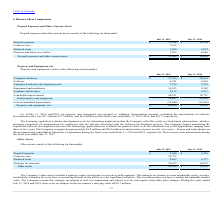From Guidewire Software's financial document, What was the Depreciation expense, excluding the amortization of software development costs in 2019, 2018 and 2017 respectively? The document contains multiple relevant values: $9.7 million, $7.7 million, $6.6 million. From the document: "development costs, was $9.7 million, $7.7 million, and $6.6 million for the fiscal years ended July 31, 2019, 2018, and 2017, respectively. developmen..." Also, What was the value of software in 2019? According to the financial document, 6,741 (in thousands). The relevant text states: "Software 6,741 4,664..." Also, What was the value of Computer hardware in 2019? According to the financial document, $17,799 (in thousands). The relevant text states: "Computer hardware $ 17,799 $ 20,614..." Additionally, In which year was Computer hardware less than 20,000 thousands? According to the financial document, 2019. The relevant text states: "July 31, 2019 July 31, 2018..." Also, can you calculate: What was the average Software value for 2018 and 2019? To answer this question, I need to perform calculations using the financial data. The calculation is: (6,741 + 4,664) / 2, which equals 5702.5 (in thousands). This is based on the information: "Software 6,741 4,664 Software 6,741 4,664..." The key data points involved are: 4,664, 6,741. Also, can you calculate: What was the change in the Capitalized software development costs from 2018 to 2019? Based on the calculation: 7,374 - 3,978, the result is 3396 (in thousands). This is based on the information: "Capitalized software development costs 7,374 3,978 Capitalized software development costs 7,374 3,978..." The key data points involved are: 3,978, 7,374. 